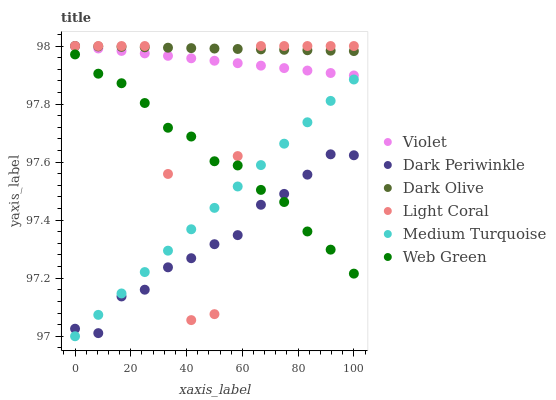Does Dark Periwinkle have the minimum area under the curve?
Answer yes or no. Yes. Does Dark Olive have the maximum area under the curve?
Answer yes or no. Yes. Does Web Green have the minimum area under the curve?
Answer yes or no. No. Does Web Green have the maximum area under the curve?
Answer yes or no. No. Is Dark Olive the smoothest?
Answer yes or no. Yes. Is Light Coral the roughest?
Answer yes or no. Yes. Is Web Green the smoothest?
Answer yes or no. No. Is Web Green the roughest?
Answer yes or no. No. Does Medium Turquoise have the lowest value?
Answer yes or no. Yes. Does Web Green have the lowest value?
Answer yes or no. No. Does Violet have the highest value?
Answer yes or no. Yes. Does Web Green have the highest value?
Answer yes or no. No. Is Dark Periwinkle less than Dark Olive?
Answer yes or no. Yes. Is Violet greater than Medium Turquoise?
Answer yes or no. Yes. Does Web Green intersect Dark Periwinkle?
Answer yes or no. Yes. Is Web Green less than Dark Periwinkle?
Answer yes or no. No. Is Web Green greater than Dark Periwinkle?
Answer yes or no. No. Does Dark Periwinkle intersect Dark Olive?
Answer yes or no. No. 